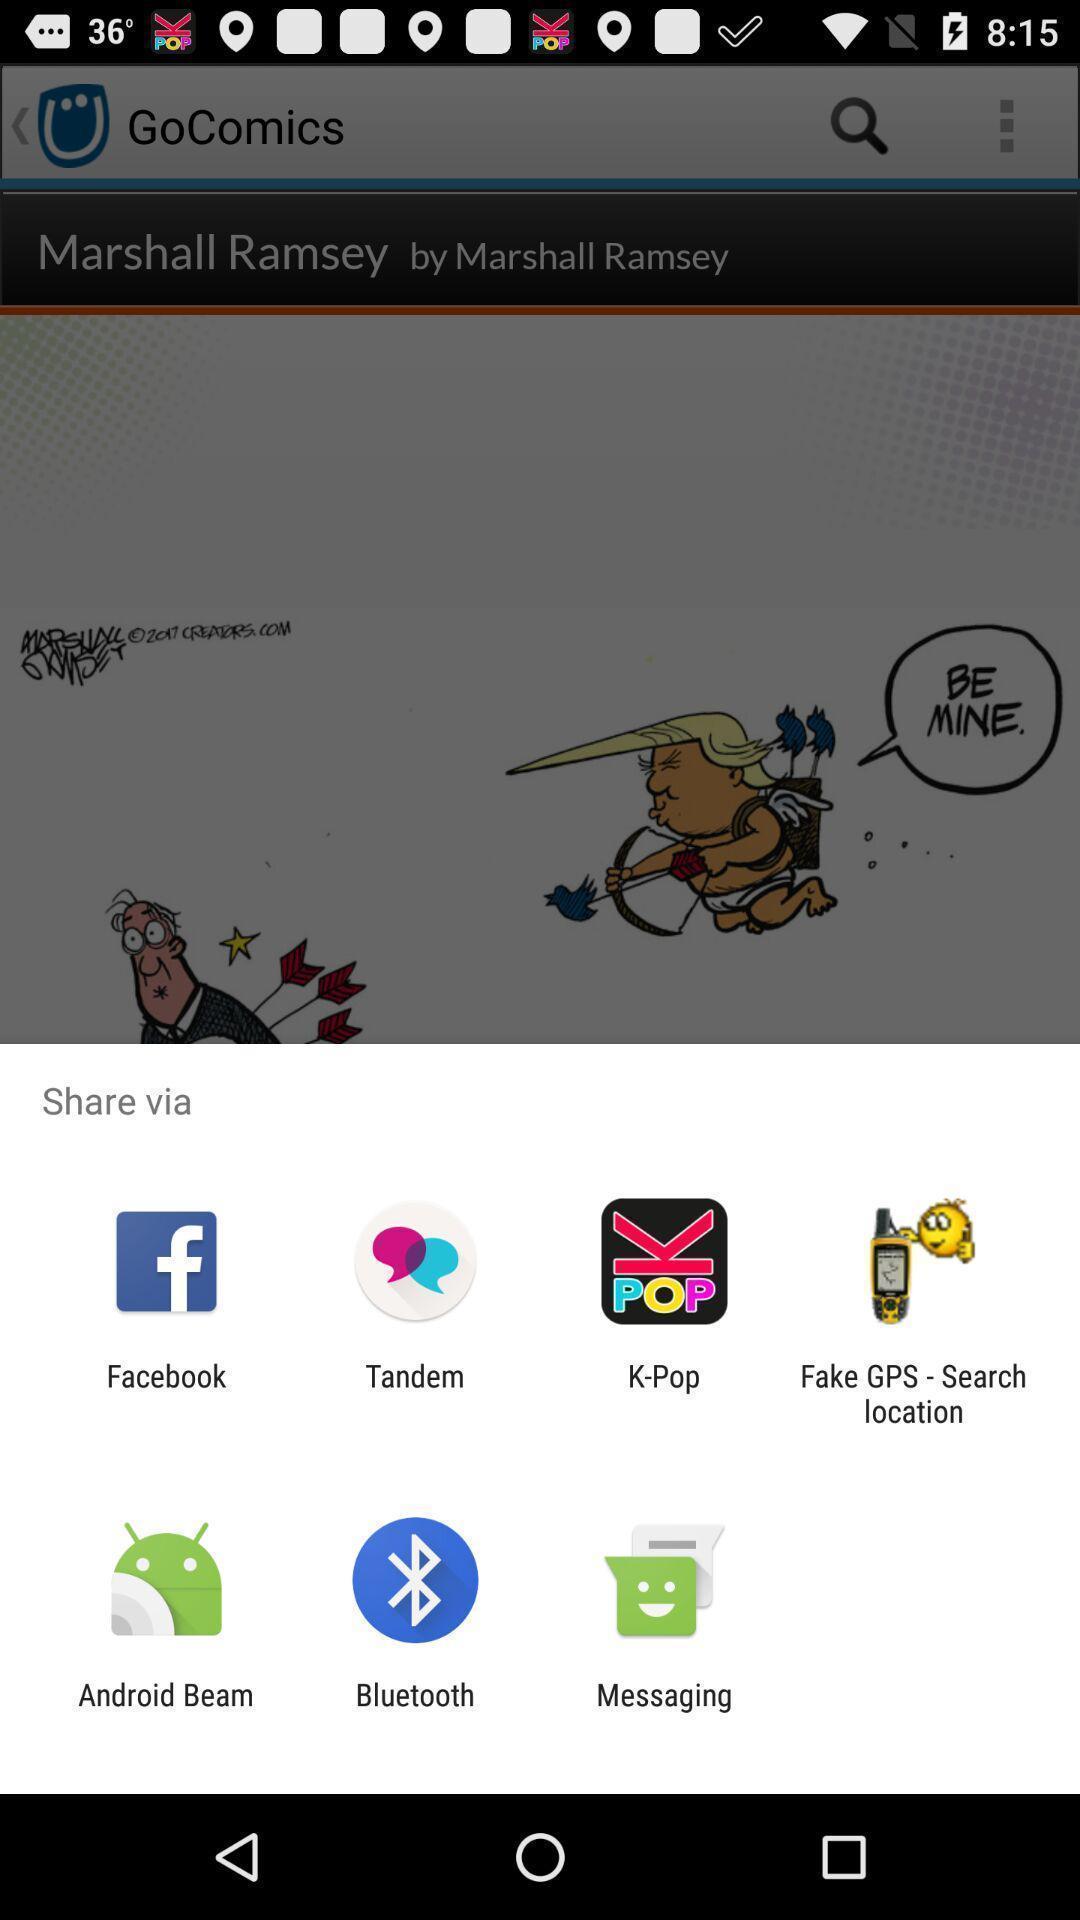Provide a description of this screenshot. Pop-up displaying list of apps to select. 